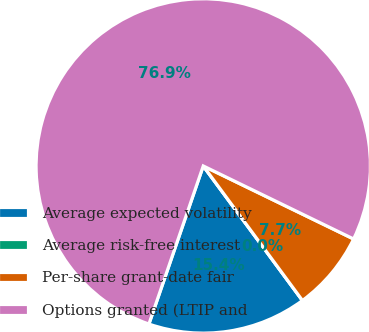Convert chart. <chart><loc_0><loc_0><loc_500><loc_500><pie_chart><fcel>Average expected volatility<fcel>Average risk-free interest<fcel>Per-share grant-date fair<fcel>Options granted (LTIP and<nl><fcel>15.38%<fcel>0.0%<fcel>7.69%<fcel>76.92%<nl></chart> 